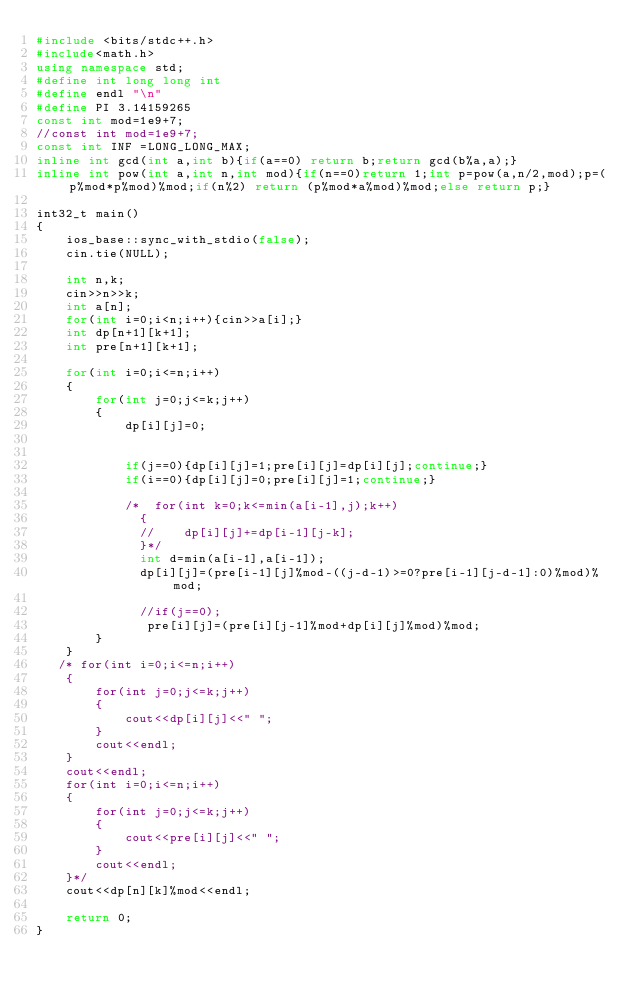Convert code to text. <code><loc_0><loc_0><loc_500><loc_500><_C++_>#include <bits/stdc++.h>
#include<math.h>
using namespace std;
#define int long long int
#define endl "\n"
#define PI 3.14159265
const int mod=1e9+7;
//const int mod=1e9+7;
const int INF =LONG_LONG_MAX;
inline int gcd(int a,int b){if(a==0) return b;return gcd(b%a,a);}
inline int pow(int a,int n,int mod){if(n==0)return 1;int p=pow(a,n/2,mod);p=(p%mod*p%mod)%mod;if(n%2) return (p%mod*a%mod)%mod;else return p;}

int32_t main()
{
    ios_base::sync_with_stdio(false);
    cin.tie(NULL);

    int n,k;
    cin>>n>>k;
    int a[n];
    for(int i=0;i<n;i++){cin>>a[i];}
    int dp[n+1][k+1];
    int pre[n+1][k+1];

    for(int i=0;i<=n;i++)
    {
        for(int j=0;j<=k;j++)
        {
            dp[i][j]=0;


            if(j==0){dp[i][j]=1;pre[i][j]=dp[i][j];continue;}
            if(i==0){dp[i][j]=0;pre[i][j]=1;continue;}

            /*  for(int k=0;k<=min(a[i-1],j);k++)
              {
              //    dp[i][j]+=dp[i-1][j-k];
              }*/
              int d=min(a[i-1],a[i-1]);
              dp[i][j]=(pre[i-1][j]%mod-((j-d-1)>=0?pre[i-1][j-d-1]:0)%mod)%mod;

              //if(j==0);
               pre[i][j]=(pre[i][j-1]%mod+dp[i][j]%mod)%mod;
        }
    }
   /* for(int i=0;i<=n;i++)
    {
        for(int j=0;j<=k;j++)
        {
            cout<<dp[i][j]<<" ";
        }
        cout<<endl;
    }
    cout<<endl;
    for(int i=0;i<=n;i++)
    {
        for(int j=0;j<=k;j++)
        {
            cout<<pre[i][j]<<" ";
        }
        cout<<endl;
    }*/
    cout<<dp[n][k]%mod<<endl;

    return 0;
}
</code> 